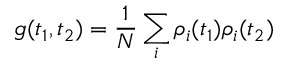<formula> <loc_0><loc_0><loc_500><loc_500>g ( t _ { 1 } , t _ { 2 } ) = \frac { 1 } { N } \sum _ { i } \rho _ { i } ( t _ { 1 } ) \rho _ { i } ( t _ { 2 } )</formula> 